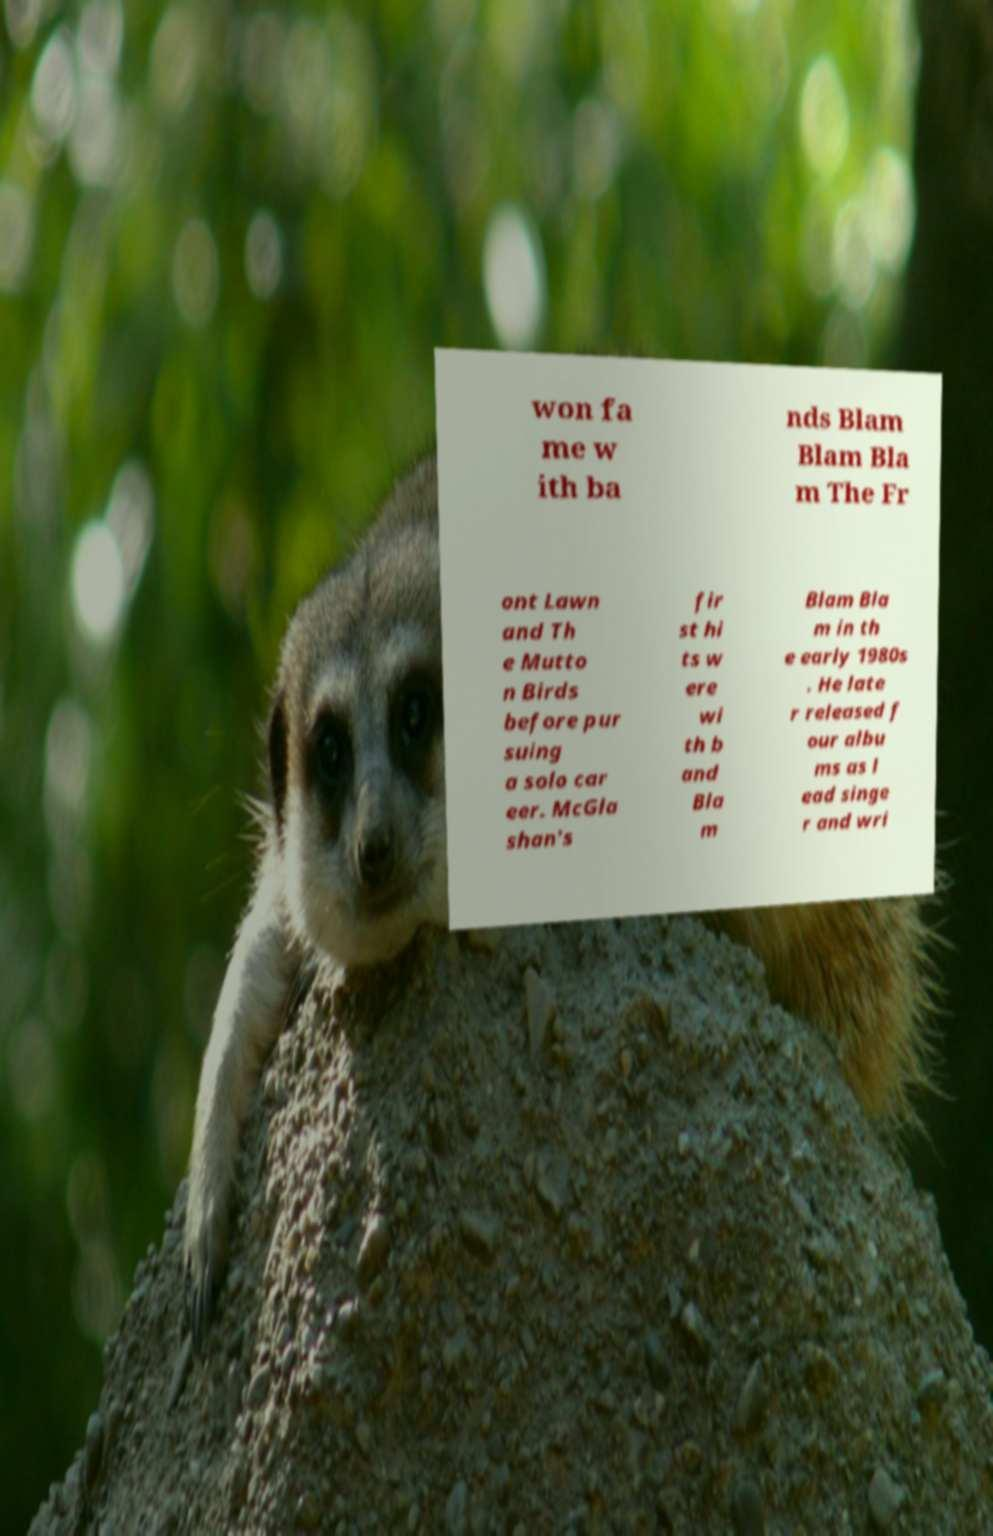Can you accurately transcribe the text from the provided image for me? won fa me w ith ba nds Blam Blam Bla m The Fr ont Lawn and Th e Mutto n Birds before pur suing a solo car eer. McGla shan's fir st hi ts w ere wi th b and Bla m Blam Bla m in th e early 1980s . He late r released f our albu ms as l ead singe r and wri 